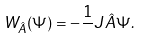<formula> <loc_0><loc_0><loc_500><loc_500>W _ { \hat { A } } ( \Psi ) = - \frac { 1 } { } J \hat { A } \Psi .</formula> 